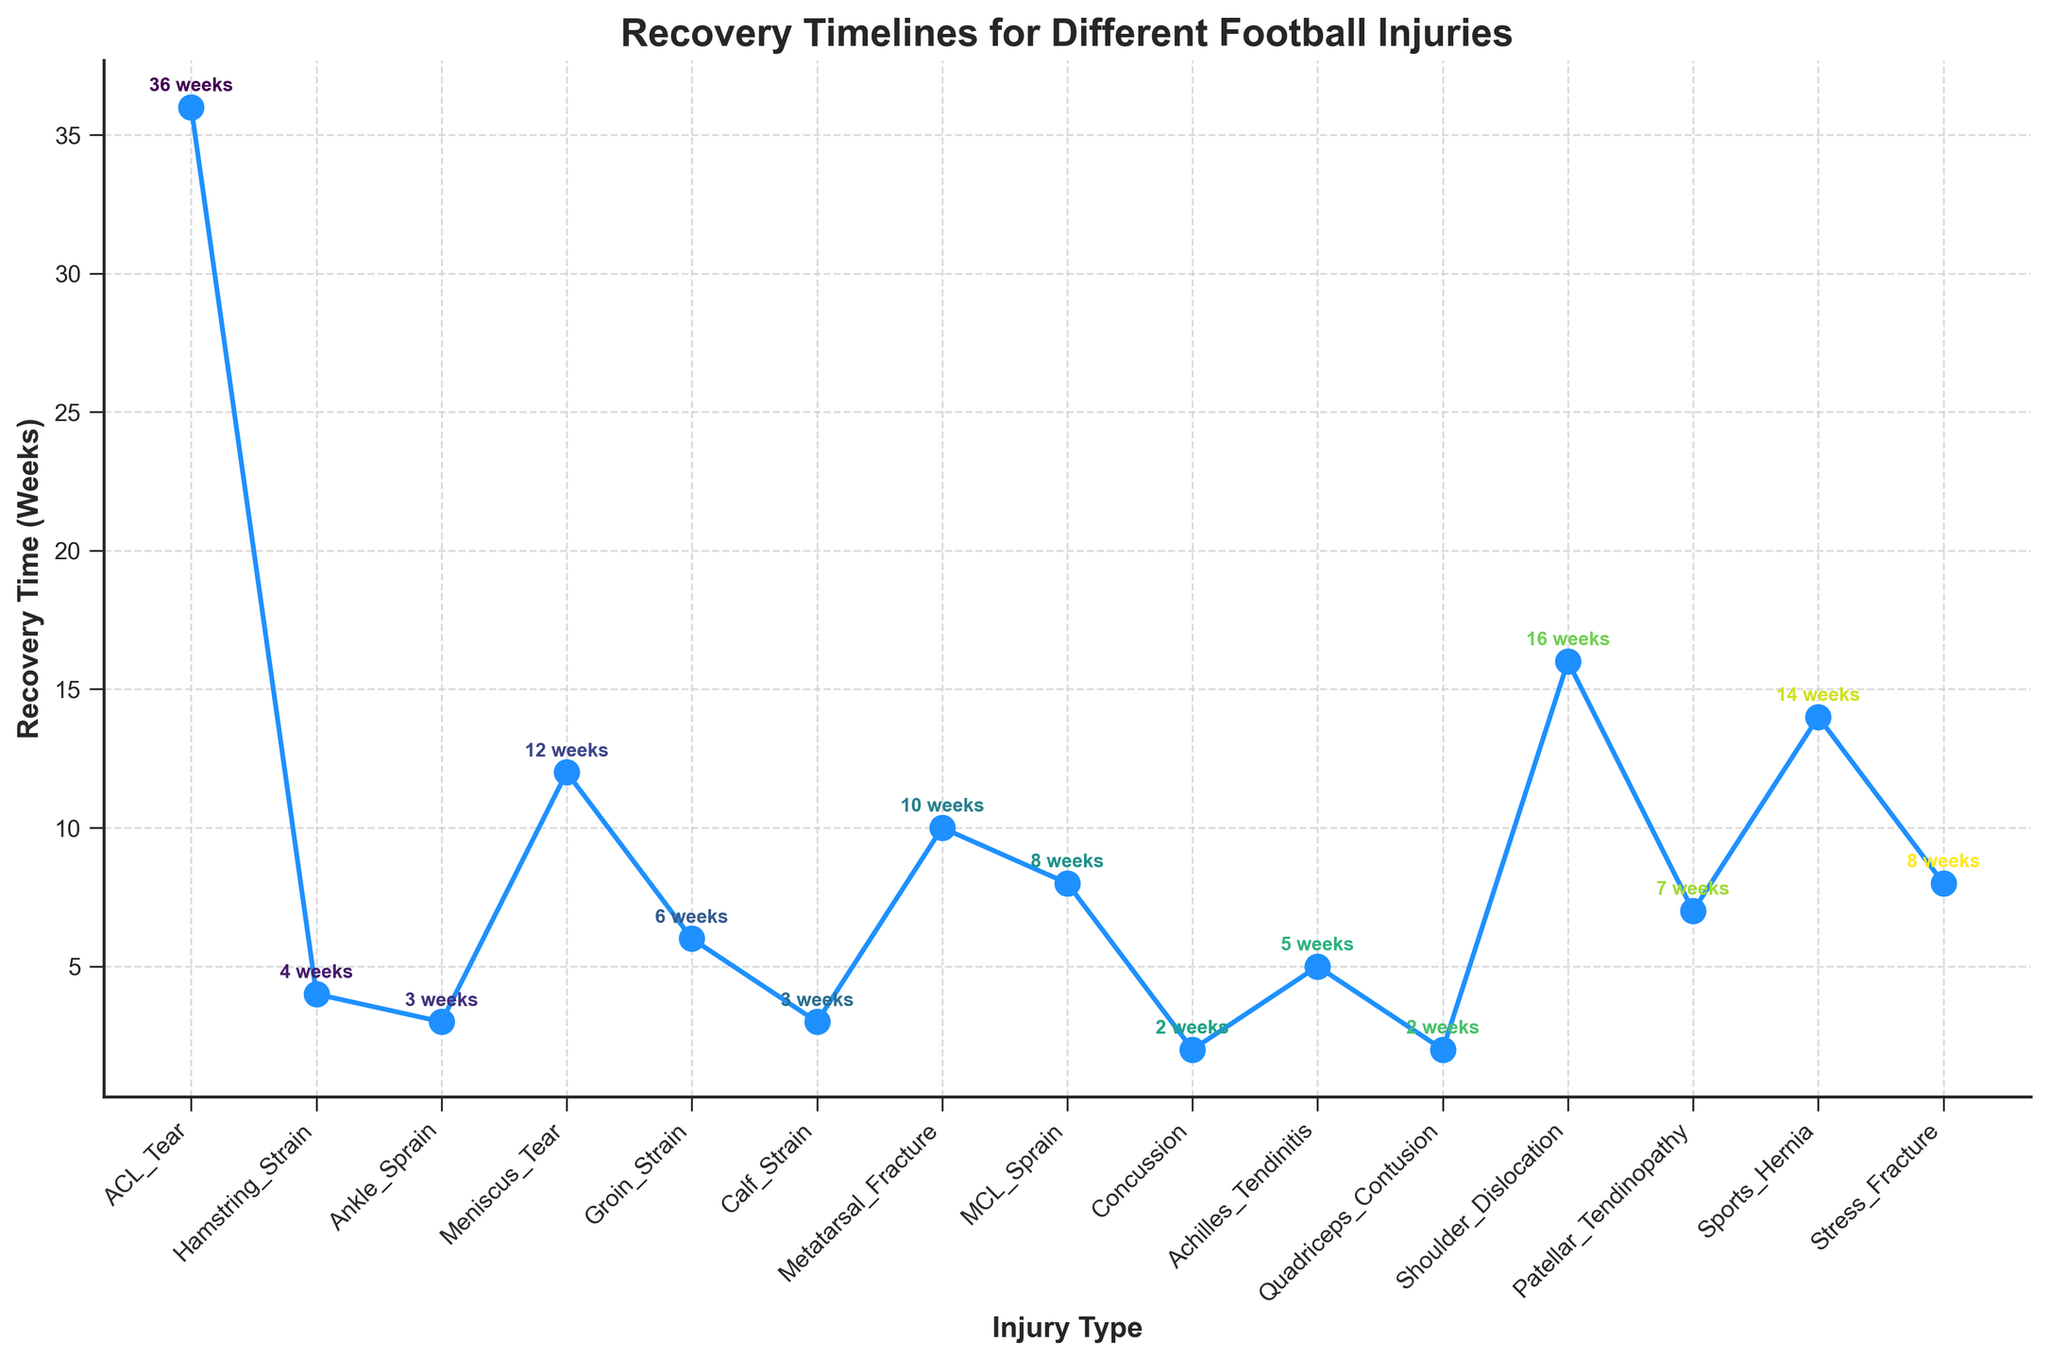What type of injury takes the longest to recover from? The injury with the longest recovery time appears to be the highest point on the chart.
Answer: ACL Tear Which injury has the shortest recovery time? The injury with the shortest recovery time is the lowest point on the chart.
Answer: Concussion How much longer does it take to recover from an ACL Tear compared to an Ankle Sprain? To find this difference, look at the vertical distance between the points for ACL Tear (36 weeks) and Ankle Sprain (3 weeks) and subtract the smaller from the larger.
Answer: 33 weeks Which rehabilitation method is used for the injury that takes 12 weeks to recover? Identify the injury with a recovery time of 12 weeks (Meniscus Tear) and then refer to the dataset for the rehabilitation method.
Answer: Arthroscopic Surgery What is the average recovery time for all injuries shown? Add up the recovery times for all injuries and divide by the number of injuries. (36+4+3+12+6+3+10+8+2+5+2+16+7+14+8) / 15 = 108 / 15
Answer: 7.2 weeks Comparing Achilles Tendinitis and Groin Strain, which has a longer recovery period? Look at the points for each injury and compare their vertical positions. Achilles Tendinitis is at 5 weeks, and Groin Strain is at 6 weeks.
Answer: Groin Strain Which two injuries have the same recovery time? Check if any two points have the same vertical position; Ankle Sprain and Calf Strain both have 3 weeks.
Answer: Ankle Sprain and Calf Strain What is the recovery time for the injury treated with Eccentric Loading Exercises? Find the rehabilitation method "Eccentric Loading Exercises" in the dataset (Achilles Tendinitis) and look at its recovery time.
Answer: 5 weeks How does the recovery time for Concussion compare to Quadriceps Contusion? Locate both injuries on the chart; both are close to 2 weeks, indicating they have similar recovery times.
Answer: Same (2 weeks) What is the total recovery time for all injuries that require a form of surgery? Identify all injuries that require surgery: ACL Tear (36 weeks), Meniscus Tear (12 weeks), Shoulder Dislocation (16 weeks), and Sports Hernia (14 weeks). Add those times: 36 + 12 + 16 + 14 = 78 weeks.
Answer: 78 weeks 